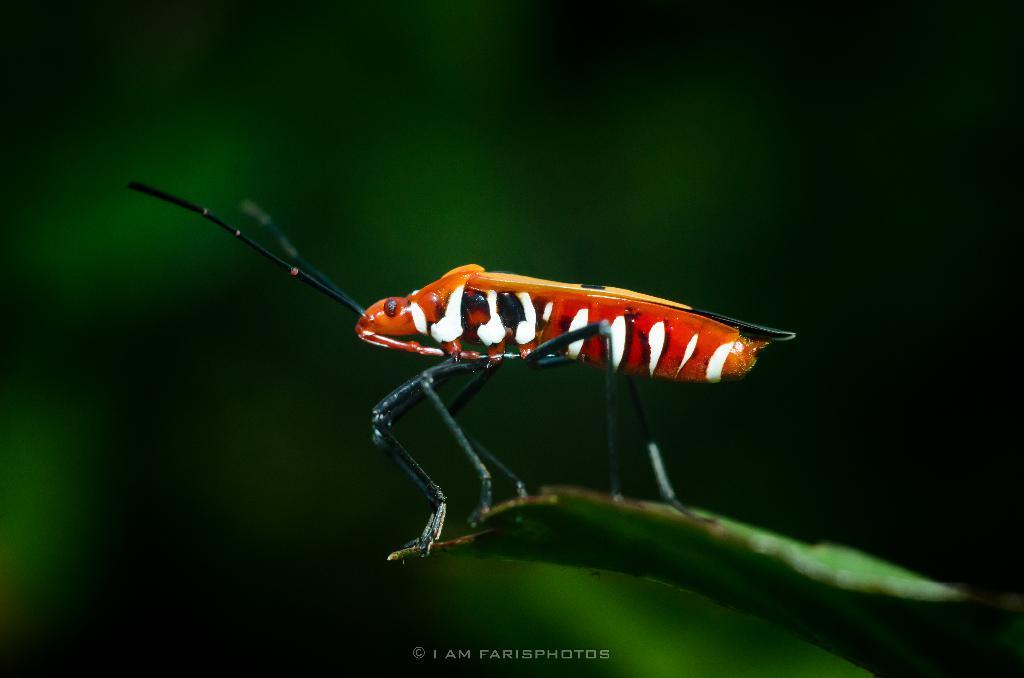Please provide a concise description of this image. In this picture we can see an insect on a leaf and in the background we can see it is blurry, at the bottom we can see some text on it. 